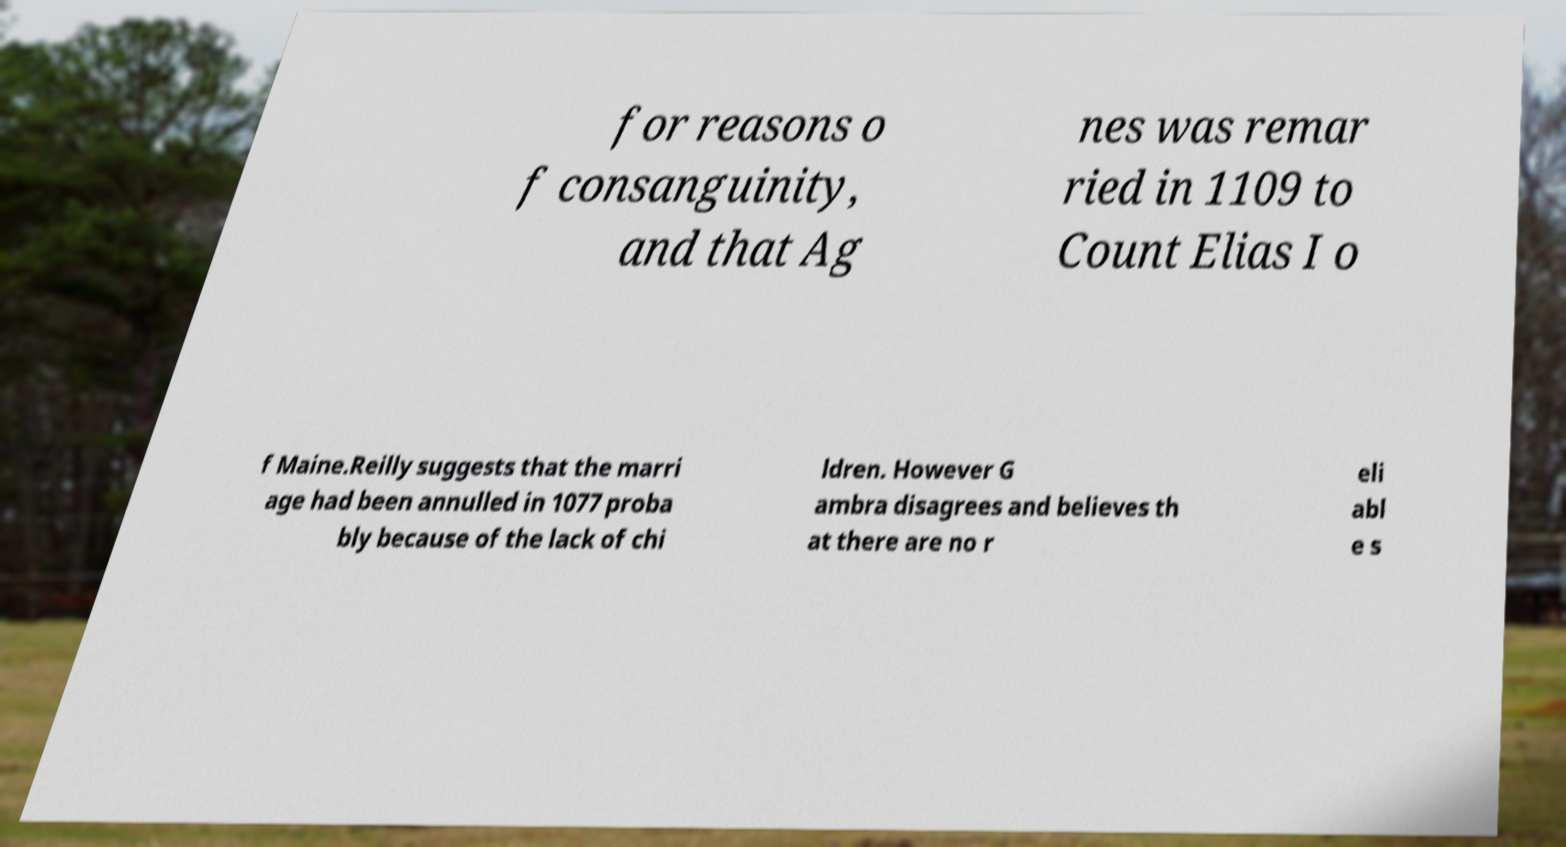Can you accurately transcribe the text from the provided image for me? for reasons o f consanguinity, and that Ag nes was remar ried in 1109 to Count Elias I o f Maine.Reilly suggests that the marri age had been annulled in 1077 proba bly because of the lack of chi ldren. However G ambra disagrees and believes th at there are no r eli abl e s 